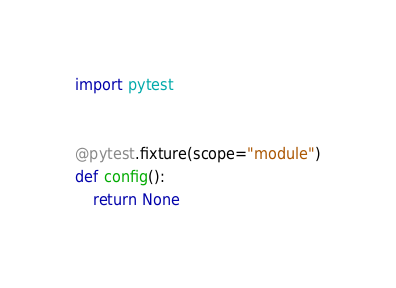Convert code to text. <code><loc_0><loc_0><loc_500><loc_500><_Python_>import pytest


@pytest.fixture(scope="module")
def config():
    return None

</code> 